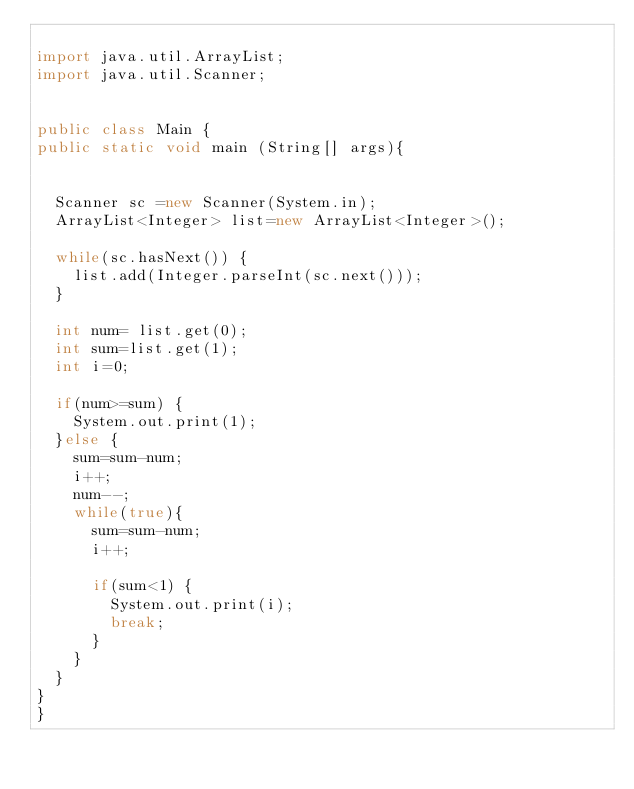Convert code to text. <code><loc_0><loc_0><loc_500><loc_500><_Java_>
import java.util.ArrayList;
import java.util.Scanner;


public class Main {
public static void main (String[] args){


	Scanner sc =new Scanner(System.in);
	ArrayList<Integer> list=new ArrayList<Integer>();

	while(sc.hasNext()) {
		list.add(Integer.parseInt(sc.next()));
	}

	int num= list.get(0);
	int sum=list.get(1);
	int i=0;
	
	if(num>=sum) {
		System.out.print(1);
	}else {
		sum=sum-num;
		i++;
		num--;
		while(true){
			sum=sum-num;
			i++;
			
			if(sum<1) {
				System.out.print(i);
				break;
			}
		}
	}
}
}

</code> 